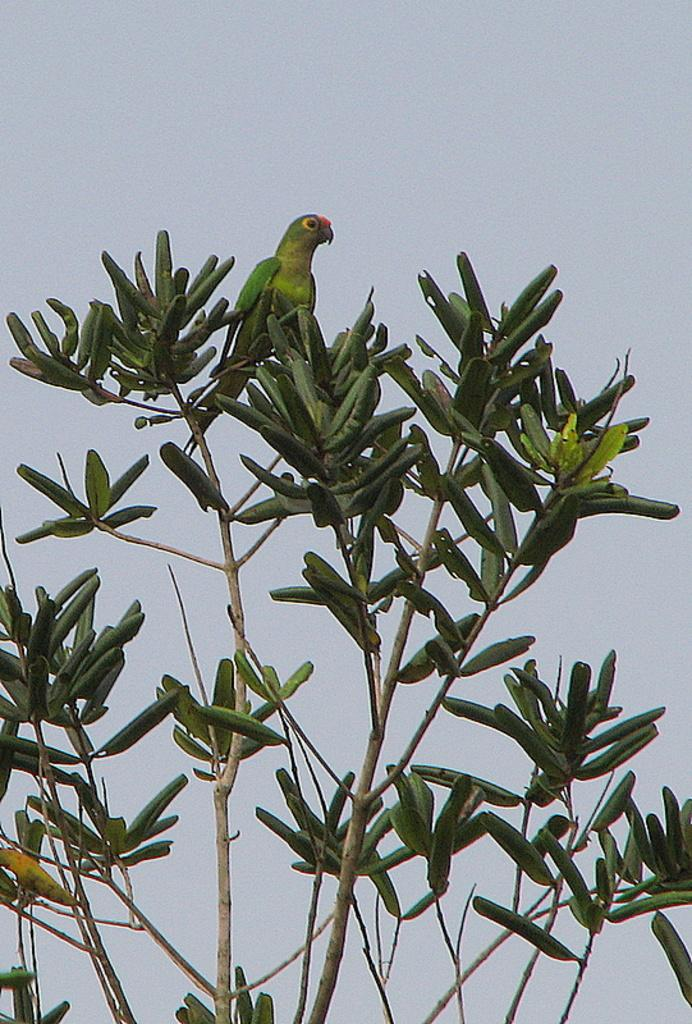What type of animal is in the image? There is a parrot in the image. Where is the parrot located? The parrot is on a tree. What can be seen in the background of the image? The sky is visible in the background of the image. What type of quill is the parrot using to write in the image? There is no quill present in the image, and parrots do not write. 